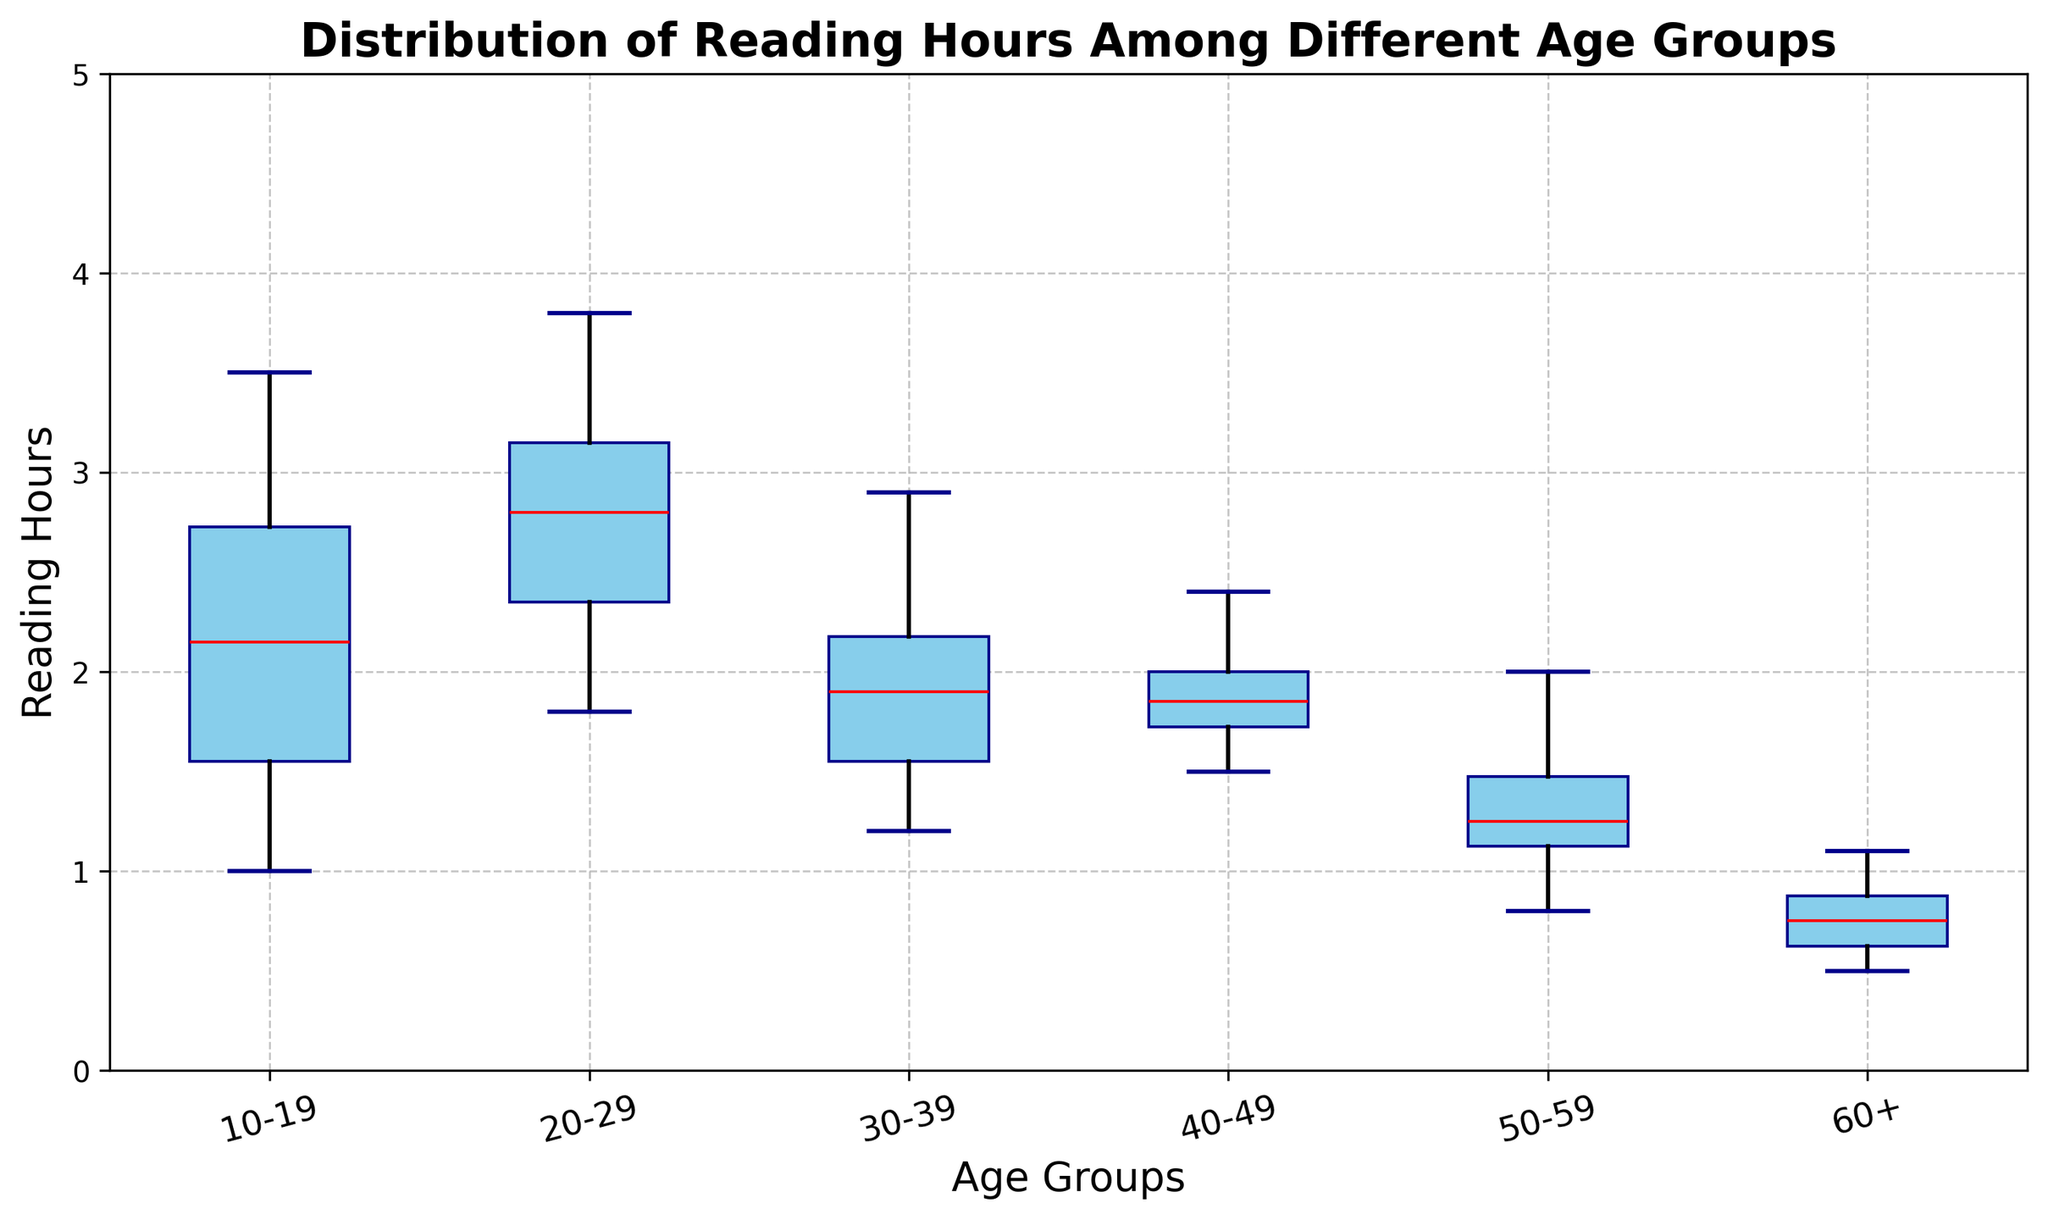What is the median reading hours for the age group 20-29? The box plot's median is indicated by the thick red line within the box corresponding to the 20-29 age group.
Answer: 2.75 Which age group has the smallest interquartile range (IQR) of reading hours? The size of the IQR can be visually assessed by the height of the box. The group with the narrowest box has the smallest IQR.
Answer: 50-59 Which age group has the highest maximum reading hours? The maximum value is indicated by the top whisker of the boxplot. Identify which age group's whisker extends the highest.
Answer: 20-29 Are there any outliers in the reading hours data for the age group 10-19? Outliers are depicted by individual points outside the whisker lines in a box plot. Check if there are any individual points for 10-19.
Answer: No What is the range of reading hours for the age group 30-39? The range is calculated by subtracting the minimum value from the maximum value. Identify these from the bottom and top whiskers of the 30-39 age group.
Answer: 1.7 Compare the median reading hours between the 40-49 and 60+ age groups. Which one has a higher median? Compare the positions of the red median lines in the boxes for ages 40-49 and 60+, the higher line represents the higher median.
Answer: 40-49 What is the median reading hours for the entire dataset? To find the combined median, look for balance points between all data points across age groups, which may require more complex calculations, but median lines shown in individual groups give an idea.
Answer: Approximately 1.8 Which age group shows the largest variability in reading hours as indicated by the box plot? The variability can be seen by the length from the bottom to the top of the whiskers and the height of the box. Identify the age group with the largest overall spread.
Answer: 20-29 What is the first quartile (Q1) value for the age group 60+? The first quartile is the bottom line of the box. Locate the bottommost part of the box for the 60+ age group.
Answer: 0.6 